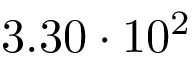Convert formula to latex. <formula><loc_0><loc_0><loc_500><loc_500>3 . 3 0 \cdot 1 0 ^ { 2 }</formula> 